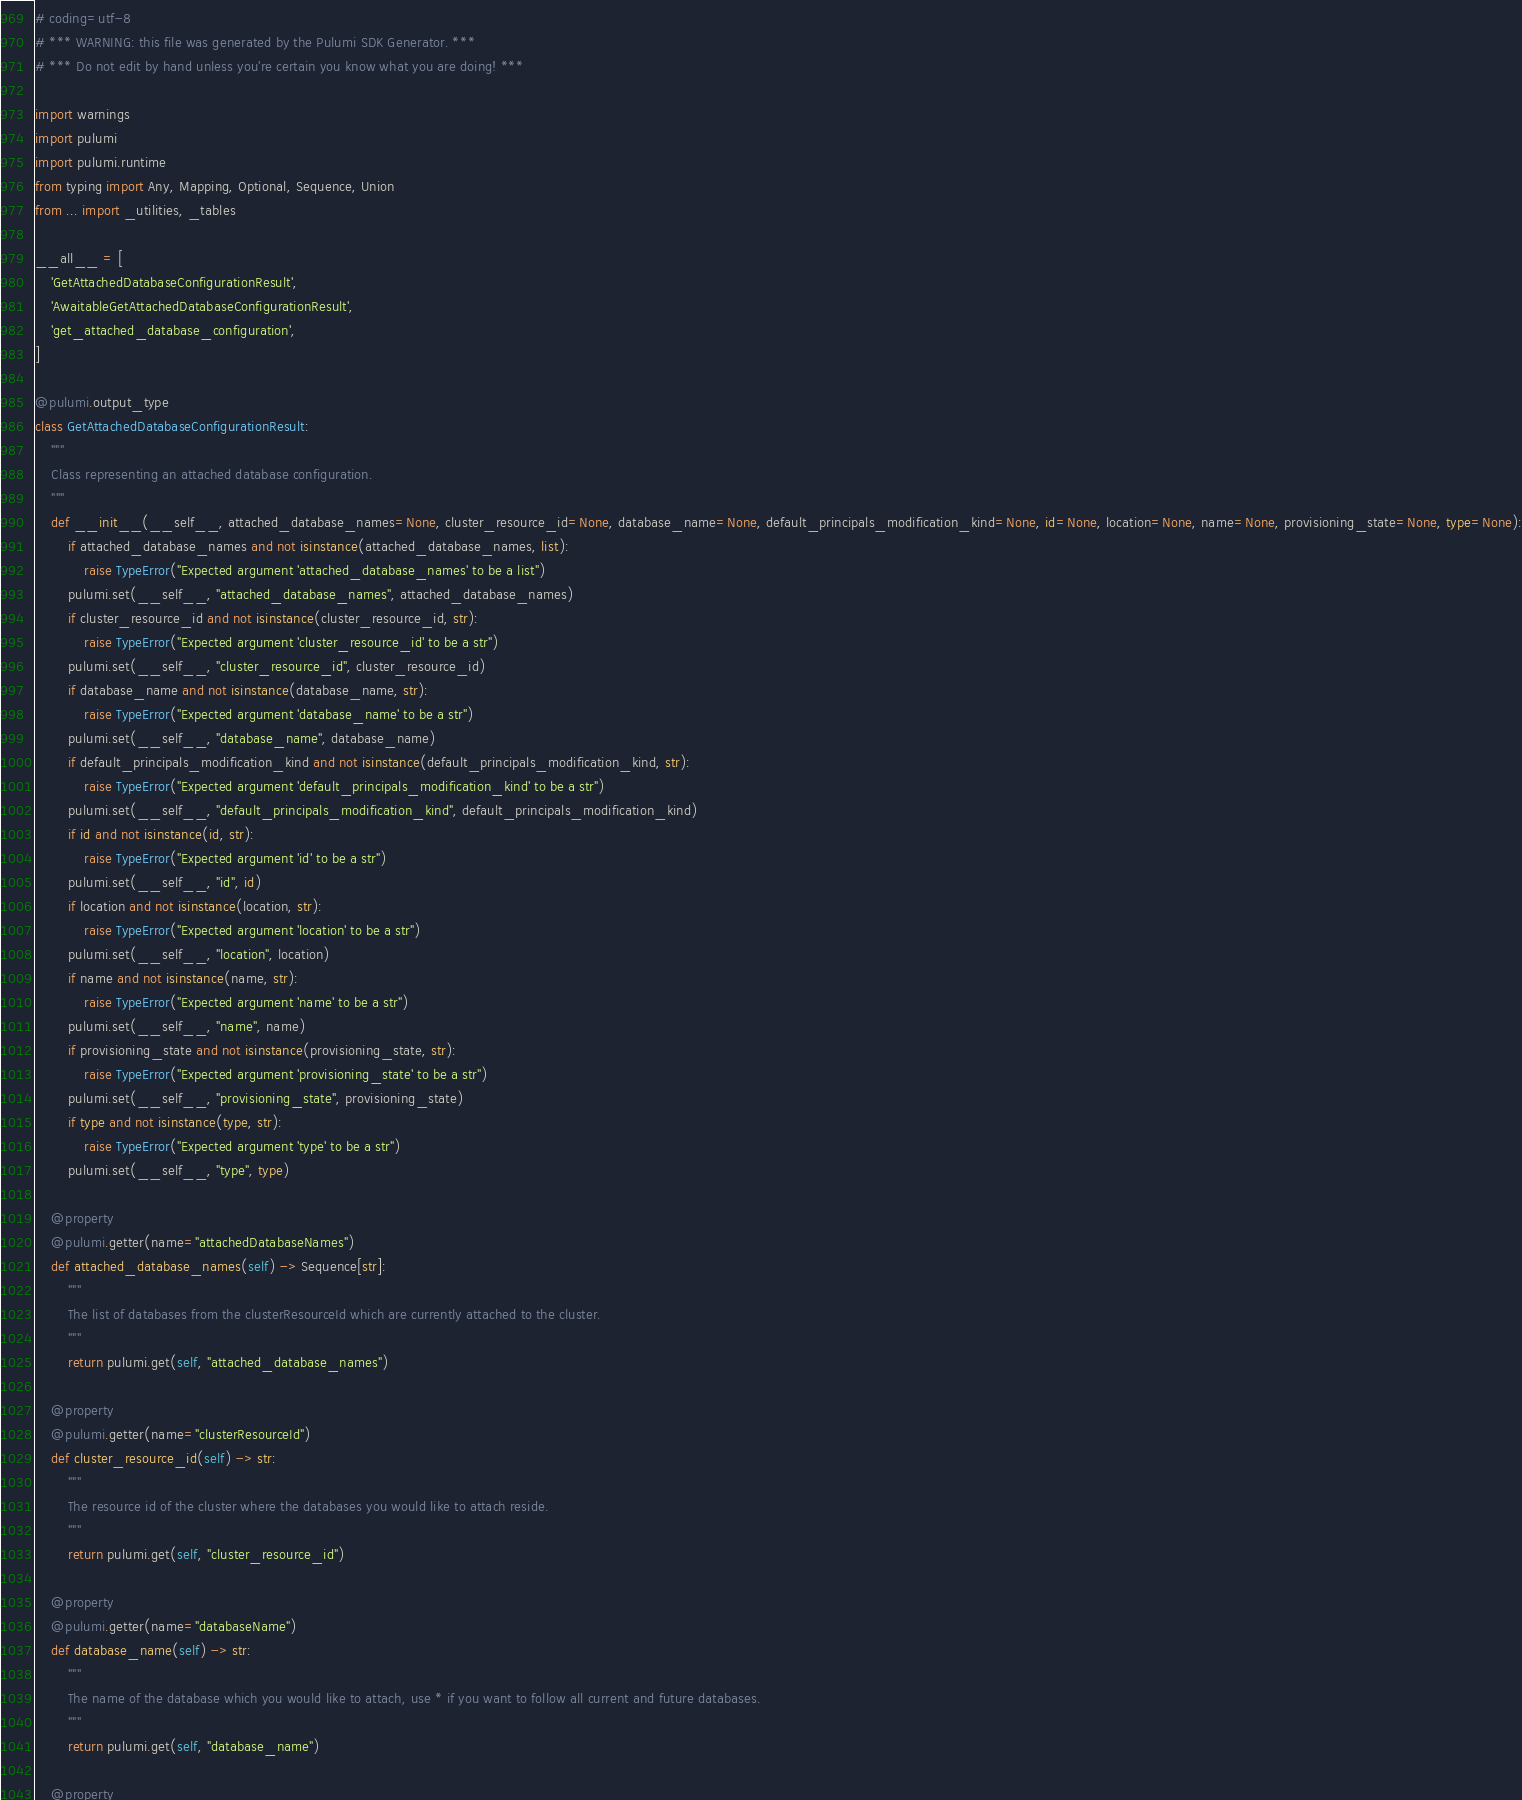Convert code to text. <code><loc_0><loc_0><loc_500><loc_500><_Python_># coding=utf-8
# *** WARNING: this file was generated by the Pulumi SDK Generator. ***
# *** Do not edit by hand unless you're certain you know what you are doing! ***

import warnings
import pulumi
import pulumi.runtime
from typing import Any, Mapping, Optional, Sequence, Union
from ... import _utilities, _tables

__all__ = [
    'GetAttachedDatabaseConfigurationResult',
    'AwaitableGetAttachedDatabaseConfigurationResult',
    'get_attached_database_configuration',
]

@pulumi.output_type
class GetAttachedDatabaseConfigurationResult:
    """
    Class representing an attached database configuration.
    """
    def __init__(__self__, attached_database_names=None, cluster_resource_id=None, database_name=None, default_principals_modification_kind=None, id=None, location=None, name=None, provisioning_state=None, type=None):
        if attached_database_names and not isinstance(attached_database_names, list):
            raise TypeError("Expected argument 'attached_database_names' to be a list")
        pulumi.set(__self__, "attached_database_names", attached_database_names)
        if cluster_resource_id and not isinstance(cluster_resource_id, str):
            raise TypeError("Expected argument 'cluster_resource_id' to be a str")
        pulumi.set(__self__, "cluster_resource_id", cluster_resource_id)
        if database_name and not isinstance(database_name, str):
            raise TypeError("Expected argument 'database_name' to be a str")
        pulumi.set(__self__, "database_name", database_name)
        if default_principals_modification_kind and not isinstance(default_principals_modification_kind, str):
            raise TypeError("Expected argument 'default_principals_modification_kind' to be a str")
        pulumi.set(__self__, "default_principals_modification_kind", default_principals_modification_kind)
        if id and not isinstance(id, str):
            raise TypeError("Expected argument 'id' to be a str")
        pulumi.set(__self__, "id", id)
        if location and not isinstance(location, str):
            raise TypeError("Expected argument 'location' to be a str")
        pulumi.set(__self__, "location", location)
        if name and not isinstance(name, str):
            raise TypeError("Expected argument 'name' to be a str")
        pulumi.set(__self__, "name", name)
        if provisioning_state and not isinstance(provisioning_state, str):
            raise TypeError("Expected argument 'provisioning_state' to be a str")
        pulumi.set(__self__, "provisioning_state", provisioning_state)
        if type and not isinstance(type, str):
            raise TypeError("Expected argument 'type' to be a str")
        pulumi.set(__self__, "type", type)

    @property
    @pulumi.getter(name="attachedDatabaseNames")
    def attached_database_names(self) -> Sequence[str]:
        """
        The list of databases from the clusterResourceId which are currently attached to the cluster.
        """
        return pulumi.get(self, "attached_database_names")

    @property
    @pulumi.getter(name="clusterResourceId")
    def cluster_resource_id(self) -> str:
        """
        The resource id of the cluster where the databases you would like to attach reside.
        """
        return pulumi.get(self, "cluster_resource_id")

    @property
    @pulumi.getter(name="databaseName")
    def database_name(self) -> str:
        """
        The name of the database which you would like to attach, use * if you want to follow all current and future databases.
        """
        return pulumi.get(self, "database_name")

    @property</code> 